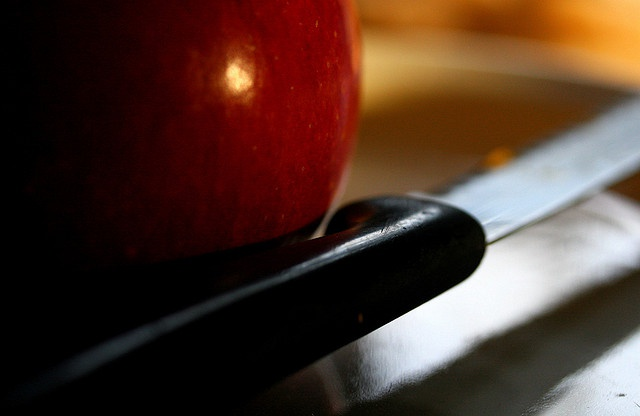Describe the objects in this image and their specific colors. I can see apple in black, maroon, and brown tones and knife in black, lightblue, darkgray, and lightgray tones in this image. 